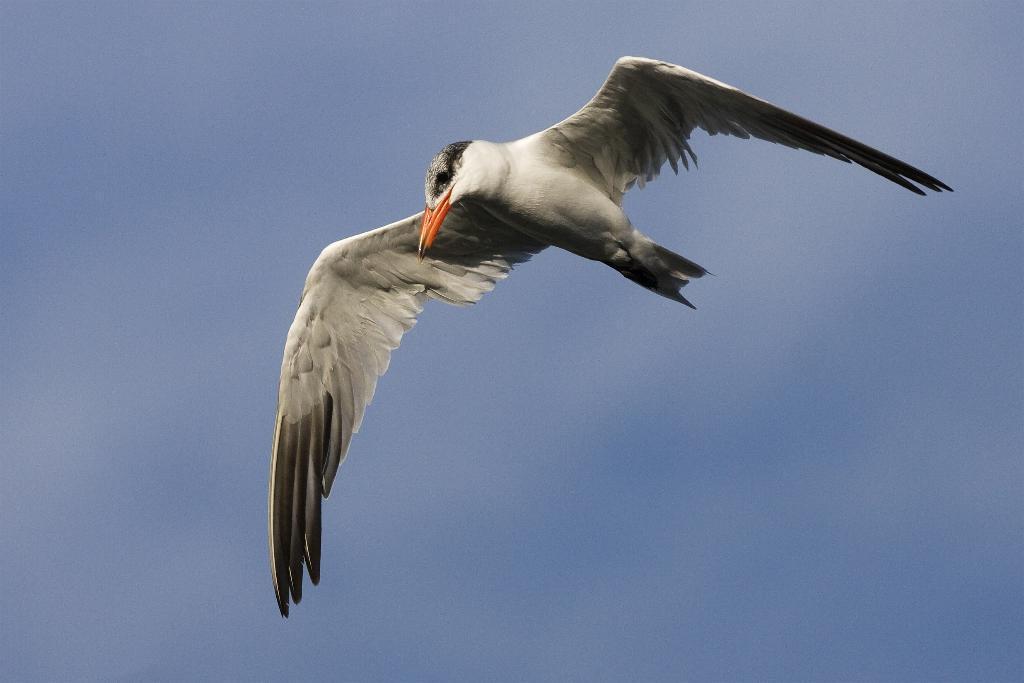How would you summarize this image in a sentence or two? This image consists of a bird which is flying in the sky in the center. 